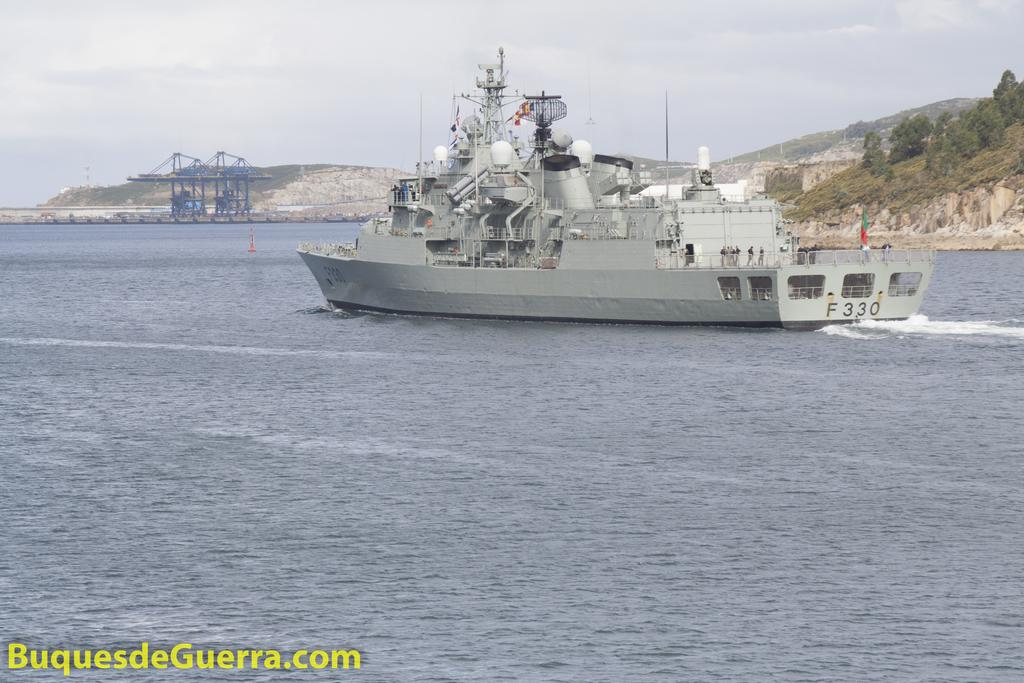<image>
Provide a brief description of the given image. Large white ship with the plate F330 is in the waters. 